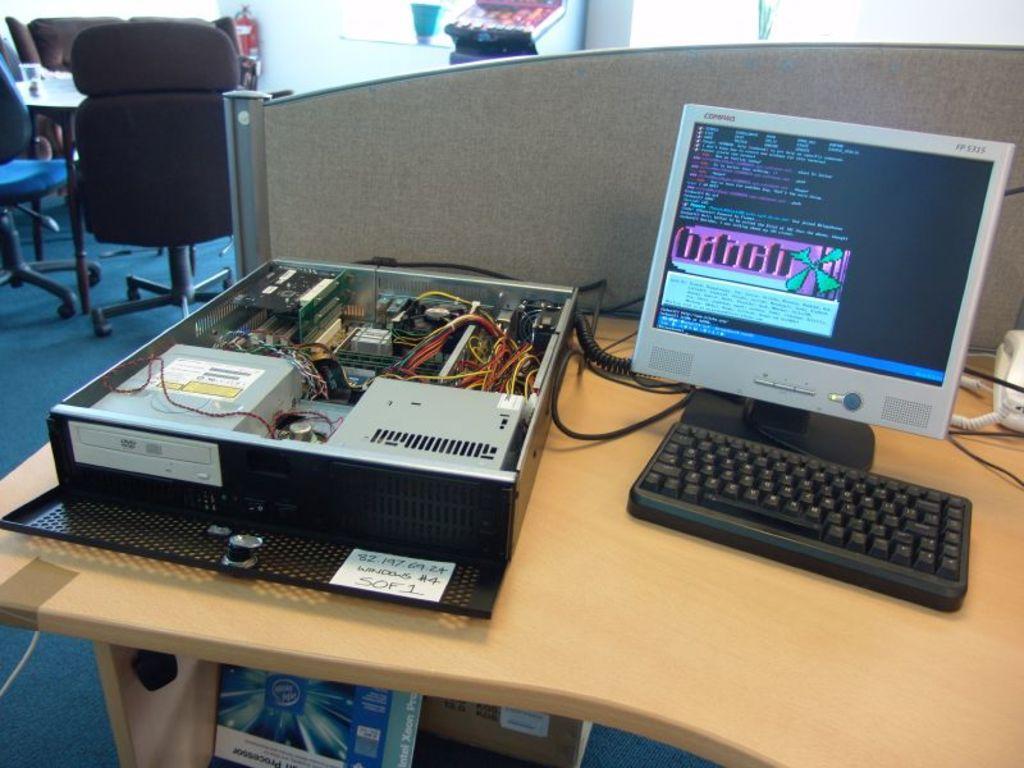Could you give a brief overview of what you see in this image? In this picture we can see table and on table we have CPU, keyboard, monitor, telephone, wires and in the background we can see chairs, wall, fire extinguisher, flower pot and under this table we have boxes. 